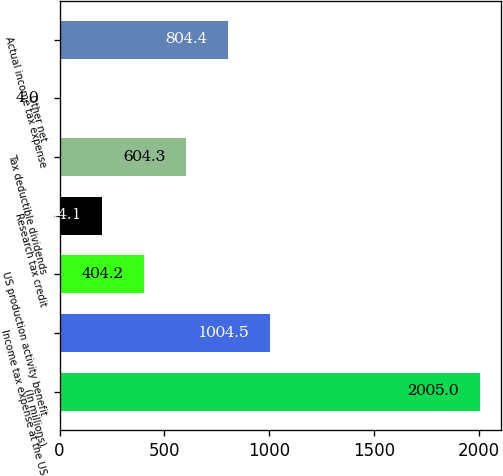<chart> <loc_0><loc_0><loc_500><loc_500><bar_chart><fcel>(In millions)<fcel>Income tax expense at the US<fcel>US production activity benefit<fcel>Research tax credit<fcel>Tax deductible dividends<fcel>Other net<fcel>Actual income tax expense<nl><fcel>2005<fcel>1004.5<fcel>404.2<fcel>204.1<fcel>604.3<fcel>4<fcel>804.4<nl></chart> 